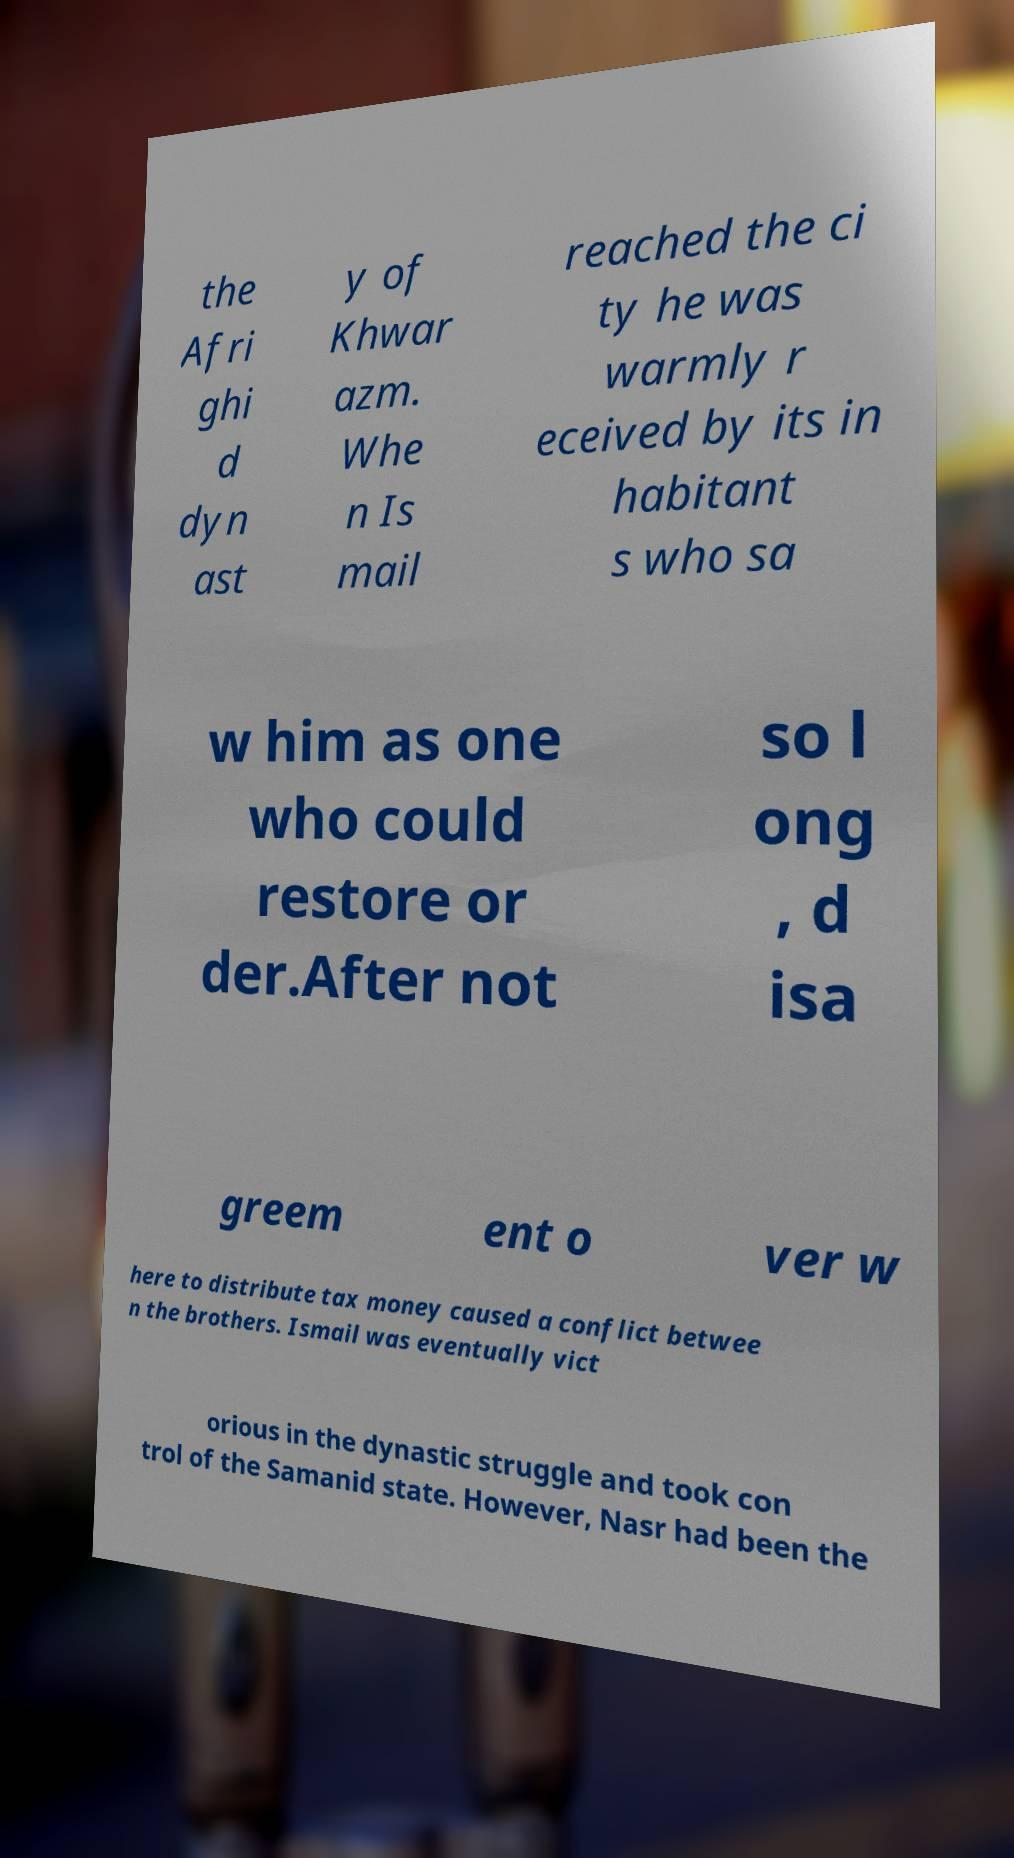Can you read and provide the text displayed in the image?This photo seems to have some interesting text. Can you extract and type it out for me? the Afri ghi d dyn ast y of Khwar azm. Whe n Is mail reached the ci ty he was warmly r eceived by its in habitant s who sa w him as one who could restore or der.After not so l ong , d isa greem ent o ver w here to distribute tax money caused a conflict betwee n the brothers. Ismail was eventually vict orious in the dynastic struggle and took con trol of the Samanid state. However, Nasr had been the 